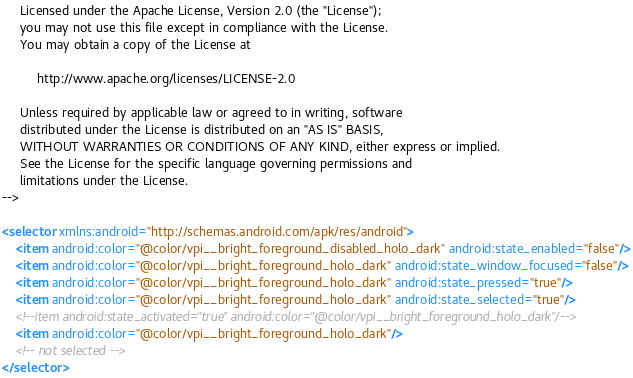Convert code to text. <code><loc_0><loc_0><loc_500><loc_500><_XML_>     Licensed under the Apache License, Version 2.0 (the "License");
     you may not use this file except in compliance with the License.
     You may obtain a copy of the License at
  
          http://www.apache.org/licenses/LICENSE-2.0
  
     Unless required by applicable law or agreed to in writing, software
     distributed under the License is distributed on an "AS IS" BASIS,
     WITHOUT WARRANTIES OR CONDITIONS OF ANY KIND, either express or implied.
     See the License for the specific language governing permissions and
     limitations under the License.
-->

<selector xmlns:android="http://schemas.android.com/apk/res/android">
    <item android:color="@color/vpi__bright_foreground_disabled_holo_dark" android:state_enabled="false"/>
    <item android:color="@color/vpi__bright_foreground_holo_dark" android:state_window_focused="false"/>
    <item android:color="@color/vpi__bright_foreground_holo_dark" android:state_pressed="true"/>
    <item android:color="@color/vpi__bright_foreground_holo_dark" android:state_selected="true"/>
    <!--item android:state_activated="true" android:color="@color/vpi__bright_foreground_holo_dark"/-->
    <item android:color="@color/vpi__bright_foreground_holo_dark"/>
    <!-- not selected -->
</selector>
</code> 